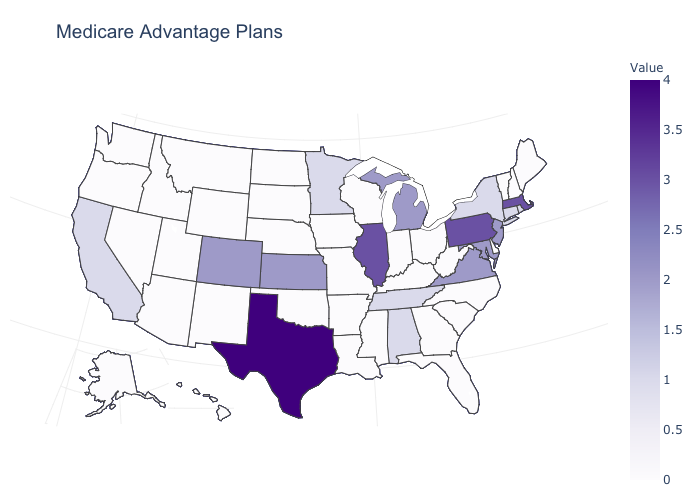Is the legend a continuous bar?
Quick response, please. Yes. Among the states that border Georgia , does South Carolina have the highest value?
Be succinct. No. Does Delaware have a higher value than Colorado?
Give a very brief answer. No. Does North Carolina have the highest value in the South?
Quick response, please. No. Among the states that border Wyoming , which have the highest value?
Quick response, please. Colorado. Does the map have missing data?
Be succinct. No. Among the states that border North Dakota , does South Dakota have the highest value?
Answer briefly. No. 